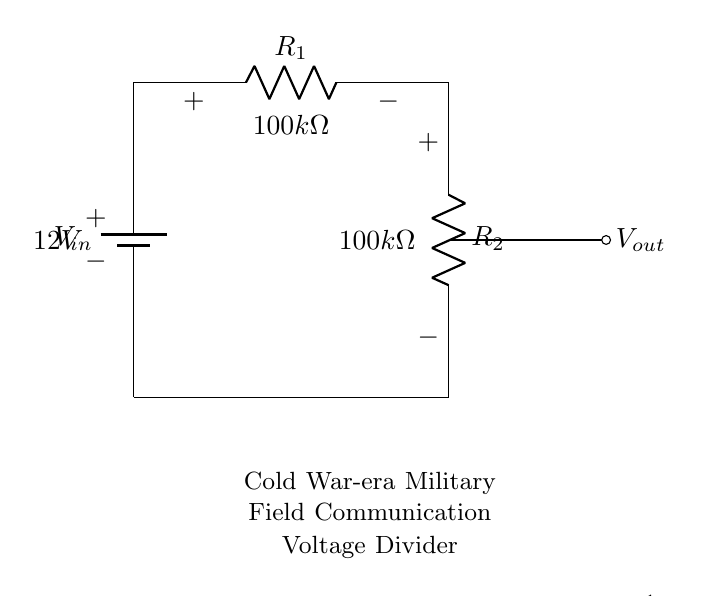What is the input voltage of the circuit? The input voltage, labeled as V_in, is indicated to be 12 volts in the circuit diagram.
Answer: 12 volts What are the resistor values in the circuit? Both resistors, R1 and R2, are shown to have equal values of 100 kilohms, as noted in the diagram.
Answer: 100 kilohms Where is the output voltage measured? The output voltage, V_out, is measured across R2, as indicated by the connection to the node just between R1 and R2.
Answer: Across R2 How many resistors are in the circuit? There are two resistors present in the voltage divider configuration, denoted as R1 and R2.
Answer: Two What type of circuit configuration is used here? The circuit is a voltage divider, which is a specific configuration used to reduce the voltage with resistors in series.
Answer: Voltage divider What will be the output voltage of this configuration? The output voltage can be calculated using the voltage divider formula, which gives V_out as 6 volts because both resistors are equal and divide the input voltage equally.
Answer: 6 volts What is the purpose of this circuit in the context of Cold War military communication devices? The voltage divider circuit is used to provide a reduced voltage level suitable for driving other components in the communication devices, ensuring reliability and functionality under operational conditions.
Answer: Voltage reduction 